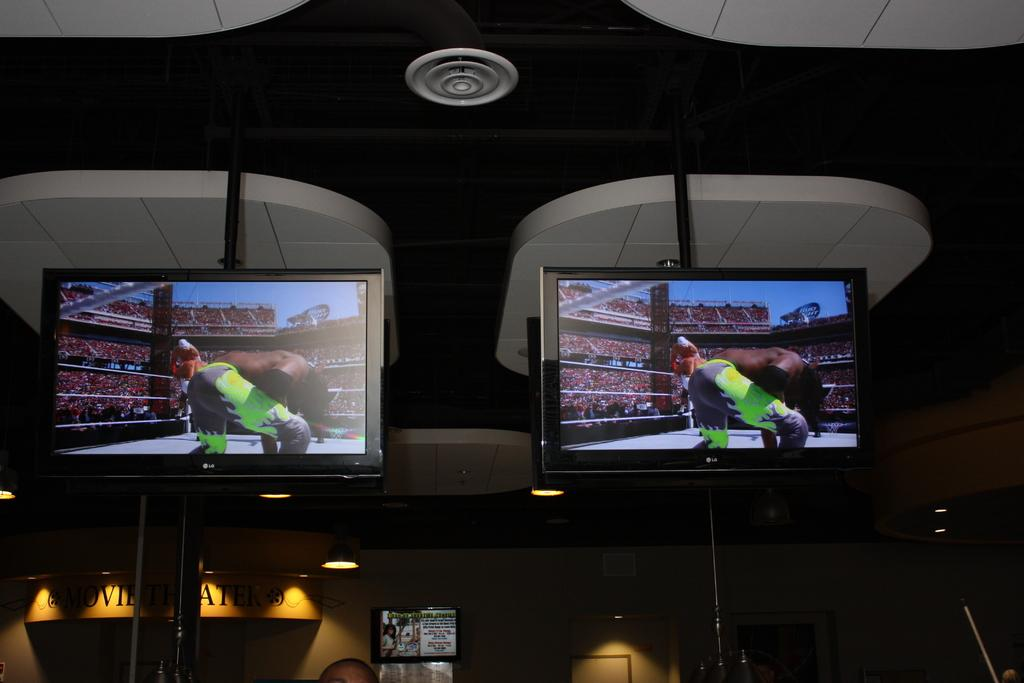<image>
Relay a brief, clear account of the picture shown. two screens above words MOVIE show a person in green pants 